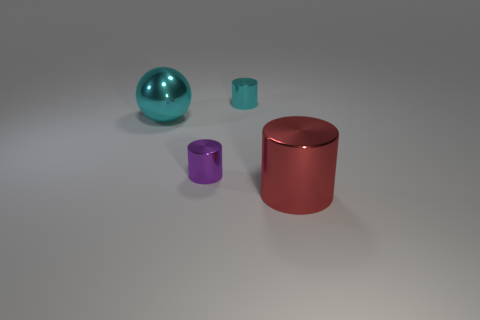Add 3 cyan metal cylinders. How many objects exist? 7 Subtract all spheres. How many objects are left? 3 Add 1 red cylinders. How many red cylinders exist? 2 Subtract 1 cyan cylinders. How many objects are left? 3 Subtract all cyan balls. Subtract all big cyan cubes. How many objects are left? 3 Add 2 cyan cylinders. How many cyan cylinders are left? 3 